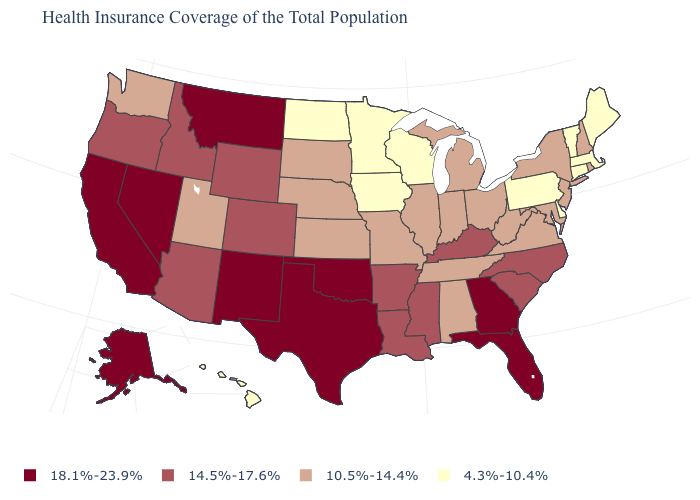What is the highest value in states that border Arizona?
Keep it brief. 18.1%-23.9%. What is the value of Minnesota?
Answer briefly. 4.3%-10.4%. Which states have the highest value in the USA?
Be succinct. Alaska, California, Florida, Georgia, Montana, Nevada, New Mexico, Oklahoma, Texas. What is the value of South Dakota?
Keep it brief. 10.5%-14.4%. What is the value of Pennsylvania?
Short answer required. 4.3%-10.4%. Is the legend a continuous bar?
Write a very short answer. No. Among the states that border Ohio , does Pennsylvania have the lowest value?
Answer briefly. Yes. What is the value of Alaska?
Concise answer only. 18.1%-23.9%. Name the states that have a value in the range 10.5%-14.4%?
Write a very short answer. Alabama, Illinois, Indiana, Kansas, Maryland, Michigan, Missouri, Nebraska, New Hampshire, New Jersey, New York, Ohio, Rhode Island, South Dakota, Tennessee, Utah, Virginia, Washington, West Virginia. Among the states that border Idaho , which have the highest value?
Quick response, please. Montana, Nevada. What is the highest value in the USA?
Short answer required. 18.1%-23.9%. What is the value of New Jersey?
Keep it brief. 10.5%-14.4%. What is the lowest value in the USA?
Be succinct. 4.3%-10.4%. What is the value of Idaho?
Write a very short answer. 14.5%-17.6%. What is the highest value in states that border Wyoming?
Quick response, please. 18.1%-23.9%. 